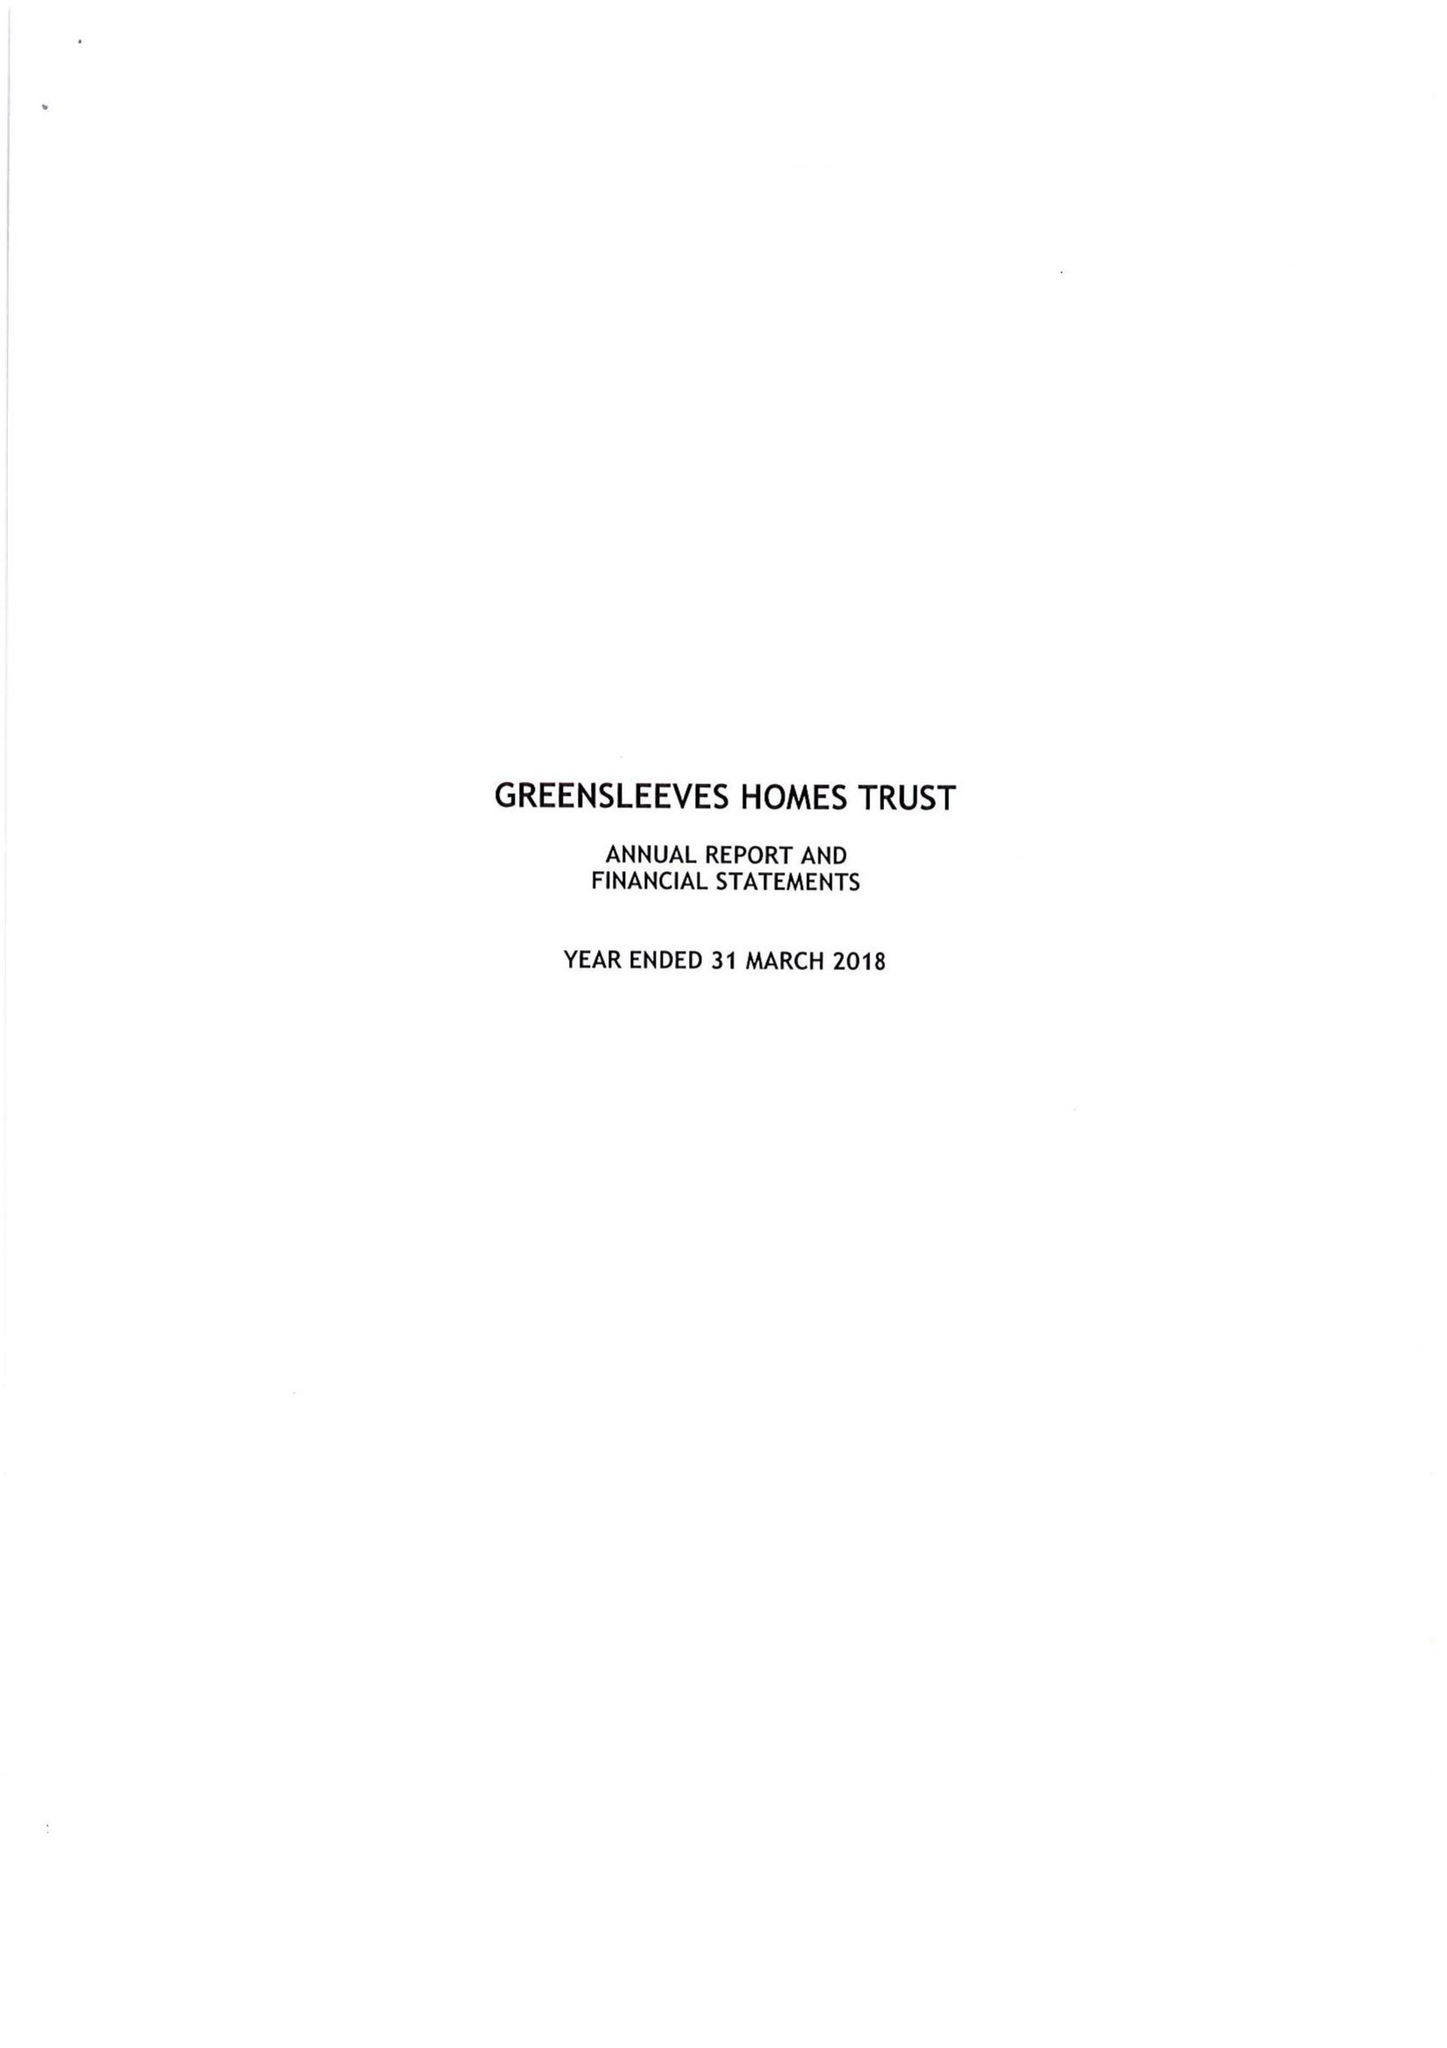What is the value for the charity_number?
Answer the question using a single word or phrase. 1060478 